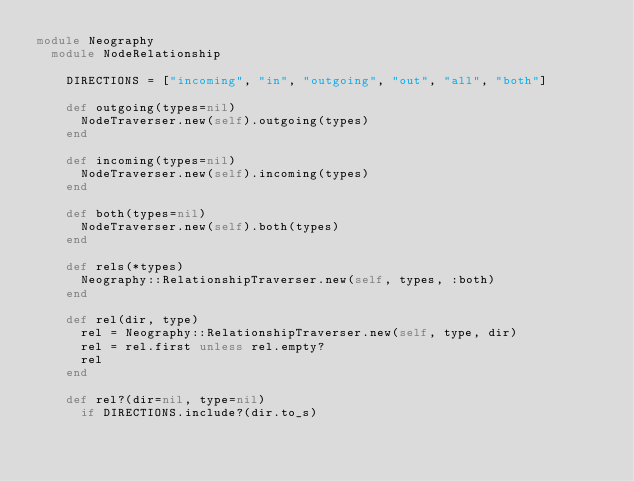Convert code to text. <code><loc_0><loc_0><loc_500><loc_500><_Ruby_>module Neography
  module NodeRelationship

    DIRECTIONS = ["incoming", "in", "outgoing", "out", "all", "both"]

    def outgoing(types=nil)
      NodeTraverser.new(self).outgoing(types)
    end

    def incoming(types=nil)
      NodeTraverser.new(self).incoming(types)
    end

    def both(types=nil)
      NodeTraverser.new(self).both(types)
    end

    def rels(*types)
      Neography::RelationshipTraverser.new(self, types, :both)
    end

    def rel(dir, type)
      rel = Neography::RelationshipTraverser.new(self, type, dir)
      rel = rel.first unless rel.empty?
      rel
    end

    def rel?(dir=nil, type=nil)
      if DIRECTIONS.include?(dir.to_s)</code> 